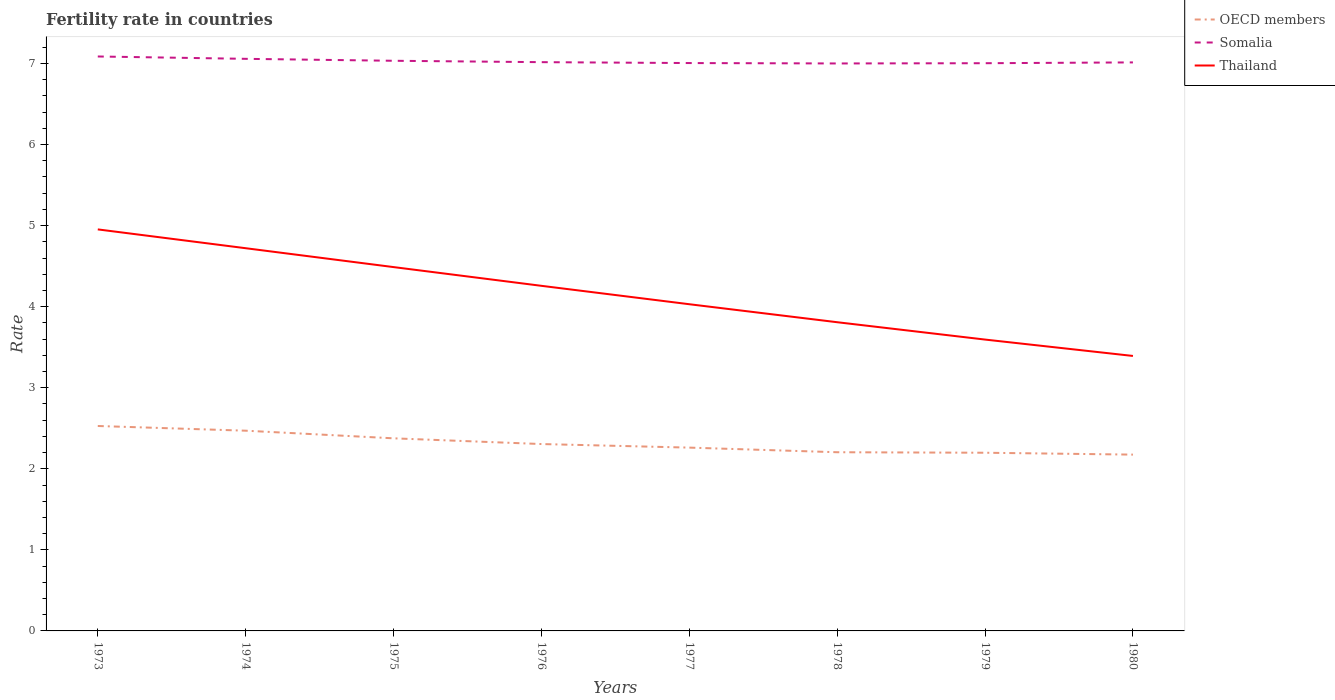Does the line corresponding to Somalia intersect with the line corresponding to OECD members?
Your answer should be very brief. No. Across all years, what is the maximum fertility rate in Somalia?
Keep it short and to the point. 7. In which year was the fertility rate in Somalia maximum?
Keep it short and to the point. 1978. What is the total fertility rate in Somalia in the graph?
Your answer should be compact. 0.01. What is the difference between the highest and the second highest fertility rate in OECD members?
Make the answer very short. 0.35. What is the difference between the highest and the lowest fertility rate in OECD members?
Offer a terse response. 3. Is the fertility rate in Somalia strictly greater than the fertility rate in OECD members over the years?
Give a very brief answer. No. How many years are there in the graph?
Provide a short and direct response. 8. What is the difference between two consecutive major ticks on the Y-axis?
Your response must be concise. 1. Does the graph contain any zero values?
Keep it short and to the point. No. Does the graph contain grids?
Ensure brevity in your answer.  No. Where does the legend appear in the graph?
Your response must be concise. Top right. How are the legend labels stacked?
Give a very brief answer. Vertical. What is the title of the graph?
Provide a short and direct response. Fertility rate in countries. What is the label or title of the X-axis?
Provide a short and direct response. Years. What is the label or title of the Y-axis?
Offer a very short reply. Rate. What is the Rate of OECD members in 1973?
Ensure brevity in your answer.  2.53. What is the Rate in Somalia in 1973?
Keep it short and to the point. 7.09. What is the Rate of Thailand in 1973?
Your response must be concise. 4.95. What is the Rate in OECD members in 1974?
Make the answer very short. 2.47. What is the Rate of Somalia in 1974?
Keep it short and to the point. 7.06. What is the Rate in Thailand in 1974?
Offer a very short reply. 4.72. What is the Rate in OECD members in 1975?
Offer a very short reply. 2.38. What is the Rate of Somalia in 1975?
Ensure brevity in your answer.  7.03. What is the Rate of Thailand in 1975?
Your answer should be very brief. 4.49. What is the Rate in OECD members in 1976?
Make the answer very short. 2.31. What is the Rate in Somalia in 1976?
Offer a very short reply. 7.02. What is the Rate in Thailand in 1976?
Offer a terse response. 4.26. What is the Rate of OECD members in 1977?
Provide a short and direct response. 2.26. What is the Rate in Somalia in 1977?
Offer a very short reply. 7. What is the Rate in Thailand in 1977?
Your response must be concise. 4.03. What is the Rate in OECD members in 1978?
Offer a very short reply. 2.2. What is the Rate of Thailand in 1978?
Provide a succinct answer. 3.81. What is the Rate in OECD members in 1979?
Provide a succinct answer. 2.2. What is the Rate of Somalia in 1979?
Your answer should be very brief. 7. What is the Rate in Thailand in 1979?
Keep it short and to the point. 3.59. What is the Rate of OECD members in 1980?
Provide a succinct answer. 2.17. What is the Rate in Somalia in 1980?
Your response must be concise. 7.01. What is the Rate of Thailand in 1980?
Make the answer very short. 3.39. Across all years, what is the maximum Rate of OECD members?
Make the answer very short. 2.53. Across all years, what is the maximum Rate of Somalia?
Provide a short and direct response. 7.09. Across all years, what is the maximum Rate in Thailand?
Provide a succinct answer. 4.95. Across all years, what is the minimum Rate in OECD members?
Your response must be concise. 2.17. Across all years, what is the minimum Rate of Thailand?
Offer a terse response. 3.39. What is the total Rate in OECD members in the graph?
Give a very brief answer. 18.52. What is the total Rate in Somalia in the graph?
Make the answer very short. 56.21. What is the total Rate in Thailand in the graph?
Your answer should be compact. 33.24. What is the difference between the Rate of OECD members in 1973 and that in 1974?
Offer a very short reply. 0.06. What is the difference between the Rate in Somalia in 1973 and that in 1974?
Your response must be concise. 0.03. What is the difference between the Rate in Thailand in 1973 and that in 1974?
Keep it short and to the point. 0.23. What is the difference between the Rate of OECD members in 1973 and that in 1975?
Offer a terse response. 0.15. What is the difference between the Rate in Somalia in 1973 and that in 1975?
Ensure brevity in your answer.  0.05. What is the difference between the Rate in Thailand in 1973 and that in 1975?
Make the answer very short. 0.47. What is the difference between the Rate of OECD members in 1973 and that in 1976?
Provide a succinct answer. 0.22. What is the difference between the Rate of Somalia in 1973 and that in 1976?
Your answer should be compact. 0.07. What is the difference between the Rate in Thailand in 1973 and that in 1976?
Give a very brief answer. 0.7. What is the difference between the Rate of OECD members in 1973 and that in 1977?
Make the answer very short. 0.27. What is the difference between the Rate of Somalia in 1973 and that in 1977?
Offer a very short reply. 0.08. What is the difference between the Rate of Thailand in 1973 and that in 1977?
Offer a very short reply. 0.92. What is the difference between the Rate in OECD members in 1973 and that in 1978?
Provide a succinct answer. 0.32. What is the difference between the Rate in Somalia in 1973 and that in 1978?
Your answer should be compact. 0.09. What is the difference between the Rate of Thailand in 1973 and that in 1978?
Give a very brief answer. 1.15. What is the difference between the Rate of OECD members in 1973 and that in 1979?
Your answer should be compact. 0.33. What is the difference between the Rate of Somalia in 1973 and that in 1979?
Your answer should be very brief. 0.08. What is the difference between the Rate of Thailand in 1973 and that in 1979?
Your response must be concise. 1.36. What is the difference between the Rate in OECD members in 1973 and that in 1980?
Ensure brevity in your answer.  0.35. What is the difference between the Rate of Somalia in 1973 and that in 1980?
Provide a short and direct response. 0.07. What is the difference between the Rate in Thailand in 1973 and that in 1980?
Offer a terse response. 1.56. What is the difference between the Rate of OECD members in 1974 and that in 1975?
Your answer should be very brief. 0.09. What is the difference between the Rate in Somalia in 1974 and that in 1975?
Provide a short and direct response. 0.02. What is the difference between the Rate of Thailand in 1974 and that in 1975?
Keep it short and to the point. 0.23. What is the difference between the Rate of OECD members in 1974 and that in 1976?
Provide a short and direct response. 0.16. What is the difference between the Rate of Somalia in 1974 and that in 1976?
Provide a short and direct response. 0.04. What is the difference between the Rate of Thailand in 1974 and that in 1976?
Your response must be concise. 0.46. What is the difference between the Rate of OECD members in 1974 and that in 1977?
Keep it short and to the point. 0.21. What is the difference between the Rate in Somalia in 1974 and that in 1977?
Your response must be concise. 0.05. What is the difference between the Rate in Thailand in 1974 and that in 1977?
Keep it short and to the point. 0.69. What is the difference between the Rate in OECD members in 1974 and that in 1978?
Offer a very short reply. 0.27. What is the difference between the Rate of Somalia in 1974 and that in 1978?
Give a very brief answer. 0.06. What is the difference between the Rate in Thailand in 1974 and that in 1978?
Your answer should be compact. 0.91. What is the difference between the Rate of OECD members in 1974 and that in 1979?
Your answer should be compact. 0.27. What is the difference between the Rate of Somalia in 1974 and that in 1979?
Make the answer very short. 0.05. What is the difference between the Rate in Thailand in 1974 and that in 1979?
Make the answer very short. 1.13. What is the difference between the Rate in OECD members in 1974 and that in 1980?
Provide a short and direct response. 0.3. What is the difference between the Rate of Somalia in 1974 and that in 1980?
Offer a terse response. 0.04. What is the difference between the Rate of Thailand in 1974 and that in 1980?
Your answer should be compact. 1.33. What is the difference between the Rate of OECD members in 1975 and that in 1976?
Provide a short and direct response. 0.07. What is the difference between the Rate in Somalia in 1975 and that in 1976?
Provide a succinct answer. 0.02. What is the difference between the Rate of Thailand in 1975 and that in 1976?
Give a very brief answer. 0.23. What is the difference between the Rate of OECD members in 1975 and that in 1977?
Your answer should be compact. 0.11. What is the difference between the Rate in Somalia in 1975 and that in 1977?
Your answer should be compact. 0.03. What is the difference between the Rate of Thailand in 1975 and that in 1977?
Provide a succinct answer. 0.46. What is the difference between the Rate in OECD members in 1975 and that in 1978?
Keep it short and to the point. 0.17. What is the difference between the Rate in Somalia in 1975 and that in 1978?
Ensure brevity in your answer.  0.03. What is the difference between the Rate of Thailand in 1975 and that in 1978?
Your response must be concise. 0.68. What is the difference between the Rate in OECD members in 1975 and that in 1979?
Provide a succinct answer. 0.18. What is the difference between the Rate in Somalia in 1975 and that in 1979?
Your response must be concise. 0.03. What is the difference between the Rate of Thailand in 1975 and that in 1979?
Offer a very short reply. 0.89. What is the difference between the Rate of OECD members in 1975 and that in 1980?
Keep it short and to the point. 0.2. What is the difference between the Rate in Somalia in 1975 and that in 1980?
Make the answer very short. 0.02. What is the difference between the Rate in Thailand in 1975 and that in 1980?
Your response must be concise. 1.1. What is the difference between the Rate in OECD members in 1976 and that in 1977?
Your answer should be compact. 0.04. What is the difference between the Rate of Somalia in 1976 and that in 1977?
Keep it short and to the point. 0.01. What is the difference between the Rate in Thailand in 1976 and that in 1977?
Your answer should be very brief. 0.23. What is the difference between the Rate in OECD members in 1976 and that in 1978?
Ensure brevity in your answer.  0.1. What is the difference between the Rate in Somalia in 1976 and that in 1978?
Give a very brief answer. 0.02. What is the difference between the Rate of Thailand in 1976 and that in 1978?
Offer a very short reply. 0.45. What is the difference between the Rate in OECD members in 1976 and that in 1979?
Offer a very short reply. 0.11. What is the difference between the Rate of Somalia in 1976 and that in 1979?
Ensure brevity in your answer.  0.01. What is the difference between the Rate of Thailand in 1976 and that in 1979?
Your answer should be compact. 0.66. What is the difference between the Rate in OECD members in 1976 and that in 1980?
Make the answer very short. 0.13. What is the difference between the Rate of Somalia in 1976 and that in 1980?
Offer a very short reply. 0. What is the difference between the Rate of Thailand in 1976 and that in 1980?
Your answer should be compact. 0.86. What is the difference between the Rate of OECD members in 1977 and that in 1978?
Offer a terse response. 0.06. What is the difference between the Rate of Somalia in 1977 and that in 1978?
Your answer should be compact. 0.01. What is the difference between the Rate in Thailand in 1977 and that in 1978?
Offer a terse response. 0.22. What is the difference between the Rate of OECD members in 1977 and that in 1979?
Your response must be concise. 0.06. What is the difference between the Rate of Somalia in 1977 and that in 1979?
Offer a terse response. 0. What is the difference between the Rate of Thailand in 1977 and that in 1979?
Make the answer very short. 0.44. What is the difference between the Rate in OECD members in 1977 and that in 1980?
Make the answer very short. 0.09. What is the difference between the Rate in Somalia in 1977 and that in 1980?
Give a very brief answer. -0.01. What is the difference between the Rate in Thailand in 1977 and that in 1980?
Your answer should be compact. 0.64. What is the difference between the Rate of OECD members in 1978 and that in 1979?
Ensure brevity in your answer.  0.01. What is the difference between the Rate of Somalia in 1978 and that in 1979?
Give a very brief answer. -0. What is the difference between the Rate in Thailand in 1978 and that in 1979?
Your answer should be compact. 0.21. What is the difference between the Rate of OECD members in 1978 and that in 1980?
Provide a succinct answer. 0.03. What is the difference between the Rate in Somalia in 1978 and that in 1980?
Provide a short and direct response. -0.01. What is the difference between the Rate in Thailand in 1978 and that in 1980?
Offer a terse response. 0.42. What is the difference between the Rate in OECD members in 1979 and that in 1980?
Your response must be concise. 0.02. What is the difference between the Rate of Somalia in 1979 and that in 1980?
Give a very brief answer. -0.01. What is the difference between the Rate of Thailand in 1979 and that in 1980?
Provide a short and direct response. 0.2. What is the difference between the Rate of OECD members in 1973 and the Rate of Somalia in 1974?
Ensure brevity in your answer.  -4.53. What is the difference between the Rate of OECD members in 1973 and the Rate of Thailand in 1974?
Offer a very short reply. -2.19. What is the difference between the Rate of Somalia in 1973 and the Rate of Thailand in 1974?
Make the answer very short. 2.37. What is the difference between the Rate in OECD members in 1973 and the Rate in Somalia in 1975?
Offer a very short reply. -4.51. What is the difference between the Rate in OECD members in 1973 and the Rate in Thailand in 1975?
Keep it short and to the point. -1.96. What is the difference between the Rate in Somalia in 1973 and the Rate in Thailand in 1975?
Provide a short and direct response. 2.6. What is the difference between the Rate of OECD members in 1973 and the Rate of Somalia in 1976?
Make the answer very short. -4.49. What is the difference between the Rate in OECD members in 1973 and the Rate in Thailand in 1976?
Make the answer very short. -1.73. What is the difference between the Rate in Somalia in 1973 and the Rate in Thailand in 1976?
Provide a short and direct response. 2.83. What is the difference between the Rate in OECD members in 1973 and the Rate in Somalia in 1977?
Provide a short and direct response. -4.48. What is the difference between the Rate of OECD members in 1973 and the Rate of Thailand in 1977?
Your answer should be compact. -1.5. What is the difference between the Rate of Somalia in 1973 and the Rate of Thailand in 1977?
Offer a terse response. 3.06. What is the difference between the Rate in OECD members in 1973 and the Rate in Somalia in 1978?
Give a very brief answer. -4.47. What is the difference between the Rate of OECD members in 1973 and the Rate of Thailand in 1978?
Your response must be concise. -1.28. What is the difference between the Rate in Somalia in 1973 and the Rate in Thailand in 1978?
Provide a short and direct response. 3.28. What is the difference between the Rate in OECD members in 1973 and the Rate in Somalia in 1979?
Make the answer very short. -4.48. What is the difference between the Rate of OECD members in 1973 and the Rate of Thailand in 1979?
Your answer should be compact. -1.07. What is the difference between the Rate of Somalia in 1973 and the Rate of Thailand in 1979?
Ensure brevity in your answer.  3.49. What is the difference between the Rate of OECD members in 1973 and the Rate of Somalia in 1980?
Make the answer very short. -4.49. What is the difference between the Rate in OECD members in 1973 and the Rate in Thailand in 1980?
Offer a very short reply. -0.86. What is the difference between the Rate of Somalia in 1973 and the Rate of Thailand in 1980?
Your answer should be very brief. 3.69. What is the difference between the Rate in OECD members in 1974 and the Rate in Somalia in 1975?
Make the answer very short. -4.56. What is the difference between the Rate in OECD members in 1974 and the Rate in Thailand in 1975?
Keep it short and to the point. -2.02. What is the difference between the Rate in Somalia in 1974 and the Rate in Thailand in 1975?
Provide a succinct answer. 2.57. What is the difference between the Rate of OECD members in 1974 and the Rate of Somalia in 1976?
Your answer should be compact. -4.55. What is the difference between the Rate of OECD members in 1974 and the Rate of Thailand in 1976?
Ensure brevity in your answer.  -1.79. What is the difference between the Rate in Somalia in 1974 and the Rate in Thailand in 1976?
Your answer should be compact. 2.8. What is the difference between the Rate in OECD members in 1974 and the Rate in Somalia in 1977?
Ensure brevity in your answer.  -4.54. What is the difference between the Rate of OECD members in 1974 and the Rate of Thailand in 1977?
Provide a succinct answer. -1.56. What is the difference between the Rate of Somalia in 1974 and the Rate of Thailand in 1977?
Offer a terse response. 3.03. What is the difference between the Rate in OECD members in 1974 and the Rate in Somalia in 1978?
Your response must be concise. -4.53. What is the difference between the Rate of OECD members in 1974 and the Rate of Thailand in 1978?
Provide a short and direct response. -1.34. What is the difference between the Rate of Somalia in 1974 and the Rate of Thailand in 1978?
Your response must be concise. 3.25. What is the difference between the Rate of OECD members in 1974 and the Rate of Somalia in 1979?
Provide a short and direct response. -4.53. What is the difference between the Rate in OECD members in 1974 and the Rate in Thailand in 1979?
Provide a succinct answer. -1.12. What is the difference between the Rate in Somalia in 1974 and the Rate in Thailand in 1979?
Make the answer very short. 3.46. What is the difference between the Rate of OECD members in 1974 and the Rate of Somalia in 1980?
Your answer should be very brief. -4.54. What is the difference between the Rate in OECD members in 1974 and the Rate in Thailand in 1980?
Give a very brief answer. -0.92. What is the difference between the Rate of Somalia in 1974 and the Rate of Thailand in 1980?
Keep it short and to the point. 3.67. What is the difference between the Rate in OECD members in 1975 and the Rate in Somalia in 1976?
Your answer should be very brief. -4.64. What is the difference between the Rate of OECD members in 1975 and the Rate of Thailand in 1976?
Ensure brevity in your answer.  -1.88. What is the difference between the Rate of Somalia in 1975 and the Rate of Thailand in 1976?
Your answer should be compact. 2.78. What is the difference between the Rate in OECD members in 1975 and the Rate in Somalia in 1977?
Give a very brief answer. -4.63. What is the difference between the Rate in OECD members in 1975 and the Rate in Thailand in 1977?
Your answer should be very brief. -1.65. What is the difference between the Rate in Somalia in 1975 and the Rate in Thailand in 1977?
Offer a very short reply. 3. What is the difference between the Rate of OECD members in 1975 and the Rate of Somalia in 1978?
Provide a short and direct response. -4.62. What is the difference between the Rate of OECD members in 1975 and the Rate of Thailand in 1978?
Offer a very short reply. -1.43. What is the difference between the Rate in Somalia in 1975 and the Rate in Thailand in 1978?
Provide a succinct answer. 3.23. What is the difference between the Rate in OECD members in 1975 and the Rate in Somalia in 1979?
Offer a terse response. -4.63. What is the difference between the Rate of OECD members in 1975 and the Rate of Thailand in 1979?
Offer a terse response. -1.22. What is the difference between the Rate in Somalia in 1975 and the Rate in Thailand in 1979?
Offer a terse response. 3.44. What is the difference between the Rate of OECD members in 1975 and the Rate of Somalia in 1980?
Your answer should be very brief. -4.64. What is the difference between the Rate of OECD members in 1975 and the Rate of Thailand in 1980?
Keep it short and to the point. -1.02. What is the difference between the Rate of Somalia in 1975 and the Rate of Thailand in 1980?
Provide a succinct answer. 3.64. What is the difference between the Rate in OECD members in 1976 and the Rate in Somalia in 1977?
Ensure brevity in your answer.  -4.7. What is the difference between the Rate of OECD members in 1976 and the Rate of Thailand in 1977?
Offer a very short reply. -1.72. What is the difference between the Rate in Somalia in 1976 and the Rate in Thailand in 1977?
Provide a succinct answer. 2.99. What is the difference between the Rate of OECD members in 1976 and the Rate of Somalia in 1978?
Provide a short and direct response. -4.69. What is the difference between the Rate of OECD members in 1976 and the Rate of Thailand in 1978?
Keep it short and to the point. -1.5. What is the difference between the Rate of Somalia in 1976 and the Rate of Thailand in 1978?
Provide a short and direct response. 3.21. What is the difference between the Rate of OECD members in 1976 and the Rate of Somalia in 1979?
Provide a succinct answer. -4.7. What is the difference between the Rate in OECD members in 1976 and the Rate in Thailand in 1979?
Make the answer very short. -1.29. What is the difference between the Rate in Somalia in 1976 and the Rate in Thailand in 1979?
Give a very brief answer. 3.42. What is the difference between the Rate in OECD members in 1976 and the Rate in Somalia in 1980?
Make the answer very short. -4.71. What is the difference between the Rate in OECD members in 1976 and the Rate in Thailand in 1980?
Your answer should be compact. -1.09. What is the difference between the Rate of Somalia in 1976 and the Rate of Thailand in 1980?
Offer a very short reply. 3.62. What is the difference between the Rate in OECD members in 1977 and the Rate in Somalia in 1978?
Make the answer very short. -4.74. What is the difference between the Rate of OECD members in 1977 and the Rate of Thailand in 1978?
Your response must be concise. -1.55. What is the difference between the Rate in Somalia in 1977 and the Rate in Thailand in 1978?
Offer a very short reply. 3.2. What is the difference between the Rate of OECD members in 1977 and the Rate of Somalia in 1979?
Offer a terse response. -4.74. What is the difference between the Rate in OECD members in 1977 and the Rate in Thailand in 1979?
Your answer should be very brief. -1.33. What is the difference between the Rate in Somalia in 1977 and the Rate in Thailand in 1979?
Provide a short and direct response. 3.41. What is the difference between the Rate of OECD members in 1977 and the Rate of Somalia in 1980?
Your response must be concise. -4.75. What is the difference between the Rate in OECD members in 1977 and the Rate in Thailand in 1980?
Your answer should be very brief. -1.13. What is the difference between the Rate in Somalia in 1977 and the Rate in Thailand in 1980?
Your answer should be compact. 3.61. What is the difference between the Rate of OECD members in 1978 and the Rate of Somalia in 1979?
Offer a very short reply. -4.8. What is the difference between the Rate in OECD members in 1978 and the Rate in Thailand in 1979?
Your response must be concise. -1.39. What is the difference between the Rate in Somalia in 1978 and the Rate in Thailand in 1979?
Provide a short and direct response. 3.41. What is the difference between the Rate of OECD members in 1978 and the Rate of Somalia in 1980?
Your answer should be compact. -4.81. What is the difference between the Rate of OECD members in 1978 and the Rate of Thailand in 1980?
Give a very brief answer. -1.19. What is the difference between the Rate of Somalia in 1978 and the Rate of Thailand in 1980?
Your answer should be compact. 3.61. What is the difference between the Rate in OECD members in 1979 and the Rate in Somalia in 1980?
Keep it short and to the point. -4.82. What is the difference between the Rate in OECD members in 1979 and the Rate in Thailand in 1980?
Ensure brevity in your answer.  -1.19. What is the difference between the Rate of Somalia in 1979 and the Rate of Thailand in 1980?
Keep it short and to the point. 3.61. What is the average Rate in OECD members per year?
Provide a short and direct response. 2.31. What is the average Rate in Somalia per year?
Provide a short and direct response. 7.03. What is the average Rate in Thailand per year?
Keep it short and to the point. 4.16. In the year 1973, what is the difference between the Rate in OECD members and Rate in Somalia?
Ensure brevity in your answer.  -4.56. In the year 1973, what is the difference between the Rate of OECD members and Rate of Thailand?
Keep it short and to the point. -2.43. In the year 1973, what is the difference between the Rate in Somalia and Rate in Thailand?
Offer a terse response. 2.13. In the year 1974, what is the difference between the Rate in OECD members and Rate in Somalia?
Give a very brief answer. -4.59. In the year 1974, what is the difference between the Rate in OECD members and Rate in Thailand?
Your answer should be compact. -2.25. In the year 1974, what is the difference between the Rate in Somalia and Rate in Thailand?
Offer a very short reply. 2.34. In the year 1975, what is the difference between the Rate of OECD members and Rate of Somalia?
Keep it short and to the point. -4.66. In the year 1975, what is the difference between the Rate of OECD members and Rate of Thailand?
Offer a terse response. -2.11. In the year 1975, what is the difference between the Rate of Somalia and Rate of Thailand?
Provide a short and direct response. 2.54. In the year 1976, what is the difference between the Rate of OECD members and Rate of Somalia?
Your answer should be very brief. -4.71. In the year 1976, what is the difference between the Rate of OECD members and Rate of Thailand?
Make the answer very short. -1.95. In the year 1976, what is the difference between the Rate of Somalia and Rate of Thailand?
Provide a short and direct response. 2.76. In the year 1977, what is the difference between the Rate in OECD members and Rate in Somalia?
Provide a short and direct response. -4.74. In the year 1977, what is the difference between the Rate of OECD members and Rate of Thailand?
Your answer should be very brief. -1.77. In the year 1977, what is the difference between the Rate in Somalia and Rate in Thailand?
Give a very brief answer. 2.98. In the year 1978, what is the difference between the Rate of OECD members and Rate of Somalia?
Your response must be concise. -4.8. In the year 1978, what is the difference between the Rate of OECD members and Rate of Thailand?
Offer a terse response. -1.6. In the year 1978, what is the difference between the Rate of Somalia and Rate of Thailand?
Provide a succinct answer. 3.19. In the year 1979, what is the difference between the Rate in OECD members and Rate in Somalia?
Your response must be concise. -4.8. In the year 1979, what is the difference between the Rate in OECD members and Rate in Thailand?
Your answer should be compact. -1.4. In the year 1979, what is the difference between the Rate in Somalia and Rate in Thailand?
Ensure brevity in your answer.  3.41. In the year 1980, what is the difference between the Rate in OECD members and Rate in Somalia?
Ensure brevity in your answer.  -4.84. In the year 1980, what is the difference between the Rate of OECD members and Rate of Thailand?
Offer a very short reply. -1.22. In the year 1980, what is the difference between the Rate in Somalia and Rate in Thailand?
Offer a very short reply. 3.62. What is the ratio of the Rate of OECD members in 1973 to that in 1974?
Provide a short and direct response. 1.02. What is the ratio of the Rate of Somalia in 1973 to that in 1974?
Offer a very short reply. 1. What is the ratio of the Rate in Thailand in 1973 to that in 1974?
Ensure brevity in your answer.  1.05. What is the ratio of the Rate in OECD members in 1973 to that in 1975?
Your answer should be very brief. 1.06. What is the ratio of the Rate in Somalia in 1973 to that in 1975?
Your answer should be compact. 1.01. What is the ratio of the Rate in Thailand in 1973 to that in 1975?
Your answer should be compact. 1.1. What is the ratio of the Rate of OECD members in 1973 to that in 1976?
Provide a short and direct response. 1.1. What is the ratio of the Rate of Thailand in 1973 to that in 1976?
Make the answer very short. 1.16. What is the ratio of the Rate in OECD members in 1973 to that in 1977?
Offer a very short reply. 1.12. What is the ratio of the Rate in Somalia in 1973 to that in 1977?
Provide a succinct answer. 1.01. What is the ratio of the Rate in Thailand in 1973 to that in 1977?
Your answer should be compact. 1.23. What is the ratio of the Rate of OECD members in 1973 to that in 1978?
Make the answer very short. 1.15. What is the ratio of the Rate in Somalia in 1973 to that in 1978?
Keep it short and to the point. 1.01. What is the ratio of the Rate of Thailand in 1973 to that in 1978?
Ensure brevity in your answer.  1.3. What is the ratio of the Rate in OECD members in 1973 to that in 1979?
Your answer should be very brief. 1.15. What is the ratio of the Rate of Somalia in 1973 to that in 1979?
Make the answer very short. 1.01. What is the ratio of the Rate in Thailand in 1973 to that in 1979?
Ensure brevity in your answer.  1.38. What is the ratio of the Rate of OECD members in 1973 to that in 1980?
Keep it short and to the point. 1.16. What is the ratio of the Rate of Somalia in 1973 to that in 1980?
Give a very brief answer. 1.01. What is the ratio of the Rate in Thailand in 1973 to that in 1980?
Give a very brief answer. 1.46. What is the ratio of the Rate of OECD members in 1974 to that in 1975?
Offer a very short reply. 1.04. What is the ratio of the Rate of Thailand in 1974 to that in 1975?
Make the answer very short. 1.05. What is the ratio of the Rate of OECD members in 1974 to that in 1976?
Your response must be concise. 1.07. What is the ratio of the Rate in Thailand in 1974 to that in 1976?
Provide a short and direct response. 1.11. What is the ratio of the Rate in OECD members in 1974 to that in 1977?
Keep it short and to the point. 1.09. What is the ratio of the Rate of Somalia in 1974 to that in 1977?
Your response must be concise. 1.01. What is the ratio of the Rate in Thailand in 1974 to that in 1977?
Offer a very short reply. 1.17. What is the ratio of the Rate in OECD members in 1974 to that in 1978?
Offer a very short reply. 1.12. What is the ratio of the Rate in Thailand in 1974 to that in 1978?
Your response must be concise. 1.24. What is the ratio of the Rate in OECD members in 1974 to that in 1979?
Your response must be concise. 1.12. What is the ratio of the Rate in Somalia in 1974 to that in 1979?
Offer a very short reply. 1.01. What is the ratio of the Rate of Thailand in 1974 to that in 1979?
Provide a succinct answer. 1.31. What is the ratio of the Rate in OECD members in 1974 to that in 1980?
Make the answer very short. 1.14. What is the ratio of the Rate of Thailand in 1974 to that in 1980?
Your answer should be very brief. 1.39. What is the ratio of the Rate in OECD members in 1975 to that in 1976?
Ensure brevity in your answer.  1.03. What is the ratio of the Rate in Thailand in 1975 to that in 1976?
Offer a terse response. 1.05. What is the ratio of the Rate in OECD members in 1975 to that in 1977?
Make the answer very short. 1.05. What is the ratio of the Rate in Somalia in 1975 to that in 1977?
Offer a terse response. 1. What is the ratio of the Rate in Thailand in 1975 to that in 1977?
Offer a very short reply. 1.11. What is the ratio of the Rate in OECD members in 1975 to that in 1978?
Offer a terse response. 1.08. What is the ratio of the Rate of Thailand in 1975 to that in 1978?
Offer a terse response. 1.18. What is the ratio of the Rate in OECD members in 1975 to that in 1979?
Your answer should be compact. 1.08. What is the ratio of the Rate of Thailand in 1975 to that in 1979?
Provide a succinct answer. 1.25. What is the ratio of the Rate of OECD members in 1975 to that in 1980?
Offer a very short reply. 1.09. What is the ratio of the Rate in Thailand in 1975 to that in 1980?
Your response must be concise. 1.32. What is the ratio of the Rate in OECD members in 1976 to that in 1977?
Provide a short and direct response. 1.02. What is the ratio of the Rate of Thailand in 1976 to that in 1977?
Give a very brief answer. 1.06. What is the ratio of the Rate in OECD members in 1976 to that in 1978?
Give a very brief answer. 1.05. What is the ratio of the Rate of Somalia in 1976 to that in 1978?
Offer a terse response. 1. What is the ratio of the Rate in Thailand in 1976 to that in 1978?
Your answer should be very brief. 1.12. What is the ratio of the Rate of OECD members in 1976 to that in 1979?
Your response must be concise. 1.05. What is the ratio of the Rate in Somalia in 1976 to that in 1979?
Make the answer very short. 1. What is the ratio of the Rate of Thailand in 1976 to that in 1979?
Provide a short and direct response. 1.18. What is the ratio of the Rate of OECD members in 1976 to that in 1980?
Keep it short and to the point. 1.06. What is the ratio of the Rate in Somalia in 1976 to that in 1980?
Provide a succinct answer. 1. What is the ratio of the Rate of Thailand in 1976 to that in 1980?
Your response must be concise. 1.25. What is the ratio of the Rate in OECD members in 1977 to that in 1978?
Your answer should be very brief. 1.03. What is the ratio of the Rate in Thailand in 1977 to that in 1978?
Give a very brief answer. 1.06. What is the ratio of the Rate of OECD members in 1977 to that in 1979?
Ensure brevity in your answer.  1.03. What is the ratio of the Rate of Somalia in 1977 to that in 1979?
Provide a succinct answer. 1. What is the ratio of the Rate of Thailand in 1977 to that in 1979?
Keep it short and to the point. 1.12. What is the ratio of the Rate in OECD members in 1977 to that in 1980?
Your answer should be compact. 1.04. What is the ratio of the Rate of Thailand in 1977 to that in 1980?
Ensure brevity in your answer.  1.19. What is the ratio of the Rate of OECD members in 1978 to that in 1979?
Provide a succinct answer. 1. What is the ratio of the Rate of Somalia in 1978 to that in 1979?
Your answer should be very brief. 1. What is the ratio of the Rate of Thailand in 1978 to that in 1979?
Your response must be concise. 1.06. What is the ratio of the Rate in OECD members in 1978 to that in 1980?
Keep it short and to the point. 1.01. What is the ratio of the Rate of Thailand in 1978 to that in 1980?
Make the answer very short. 1.12. What is the ratio of the Rate in OECD members in 1979 to that in 1980?
Provide a short and direct response. 1.01. What is the ratio of the Rate of Thailand in 1979 to that in 1980?
Your answer should be very brief. 1.06. What is the difference between the highest and the second highest Rate of OECD members?
Offer a terse response. 0.06. What is the difference between the highest and the second highest Rate of Somalia?
Provide a succinct answer. 0.03. What is the difference between the highest and the second highest Rate in Thailand?
Give a very brief answer. 0.23. What is the difference between the highest and the lowest Rate of OECD members?
Your answer should be compact. 0.35. What is the difference between the highest and the lowest Rate in Somalia?
Ensure brevity in your answer.  0.09. What is the difference between the highest and the lowest Rate of Thailand?
Keep it short and to the point. 1.56. 